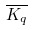Convert formula to latex. <formula><loc_0><loc_0><loc_500><loc_500>\overline { K _ { q } }</formula> 